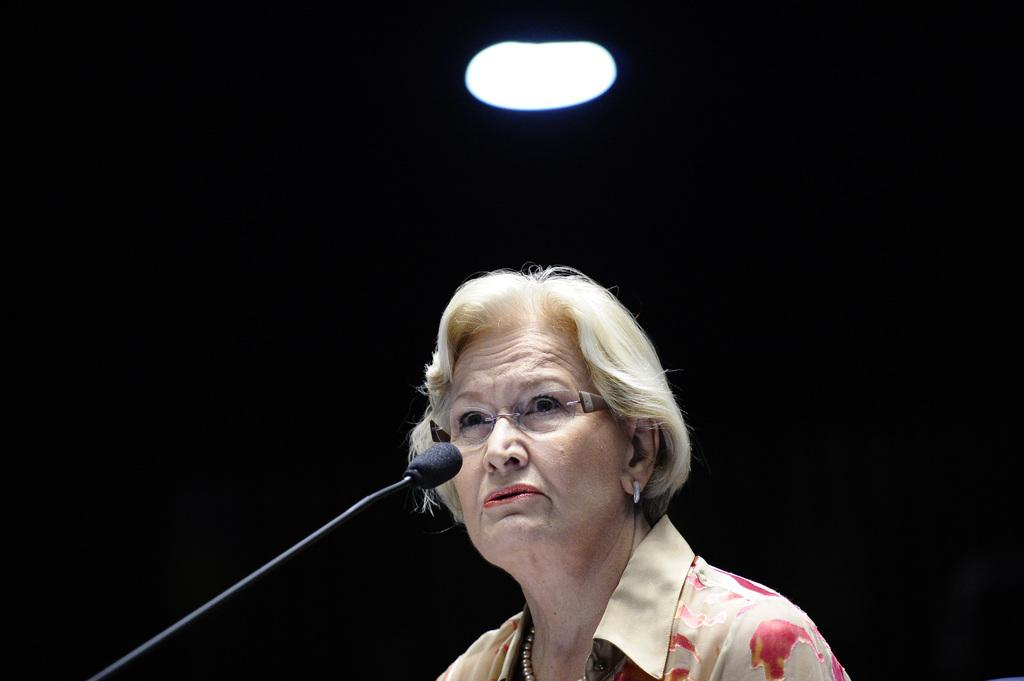What is the hair color of the woman in the image? The woman in the image has blond hair. What accessory is the woman wearing? The woman is wearing a necklace. What color is the shirt the woman is wearing? The woman is wearing a brown shirt. What is the woman doing in the image? The woman is talking on a mic. What can be seen above the woman in the image? There is a ceiling in the image, and a light is on the ceiling. What type of cakes are being sold at the industry event in the image? There is no mention of an industry event or cakes in the image; it features a blond-haired woman talking on a mic. 